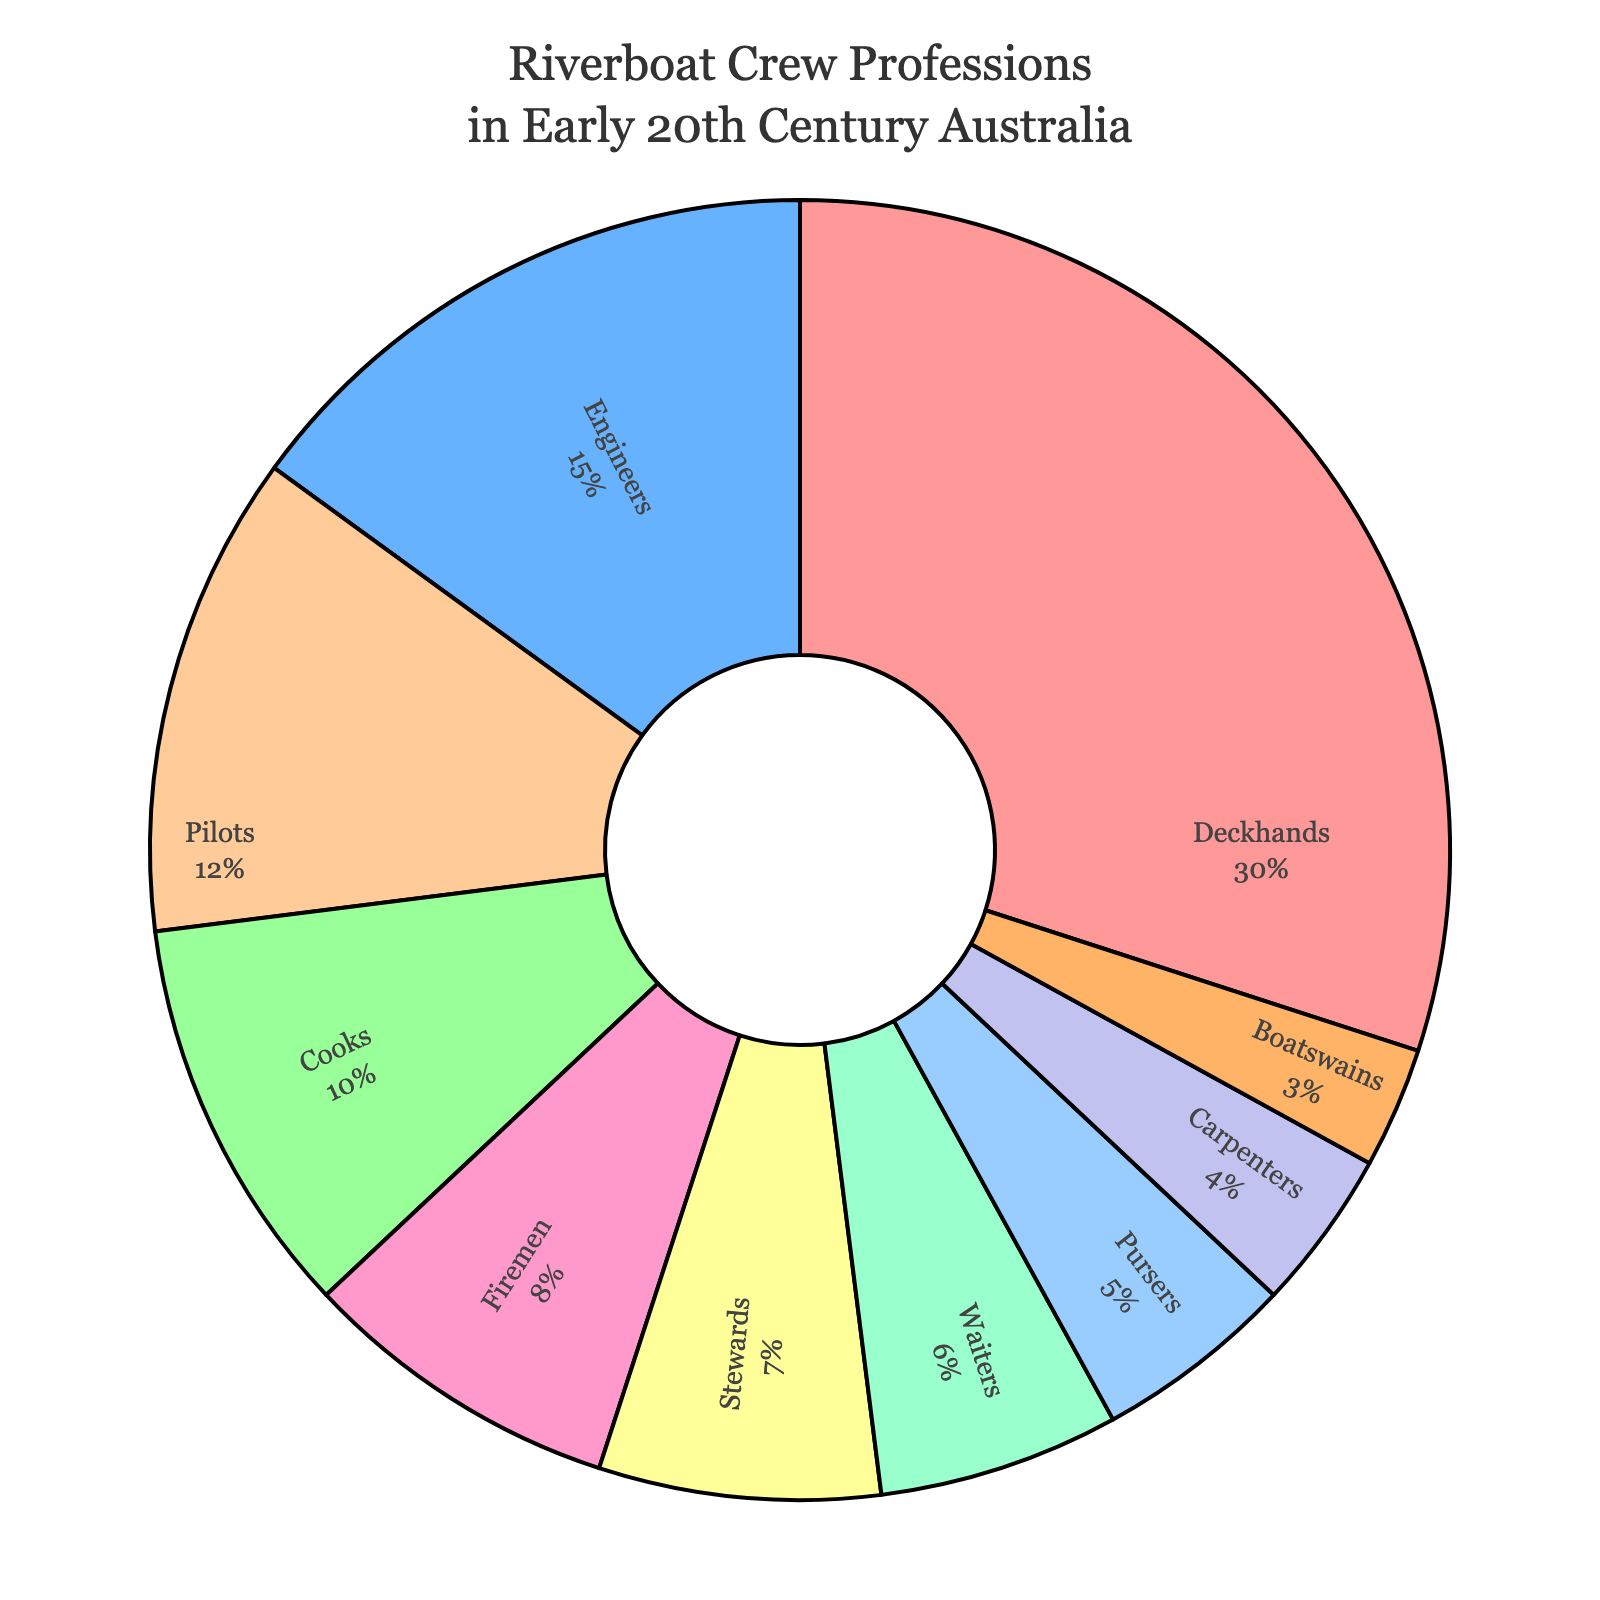Which profession has the highest percentage among riverboat crew members? The largest segment in the pie chart is for Deckhands, which has the highest percentage according to the legend.
Answer: Deckhands What is the total percentage of Deckhands, Engineers, and Cooks combined? To find the total percentage, add the individual percentages of these professions: Deckhands (30%), Engineers (15%), and Cooks (10%). So, 30% + 15% + 10% = 55%.
Answer: 55% Which profession has a smaller percentage: Stewards or Cooks? By comparing the two sections of the pie chart, we see that Cooks have 10% while Stewards have 7%, so Stewards have a smaller percentage.
Answer: Stewards What is the difference in percentage points between the professions with the highest and lowest percentages? The highest percentage is for Deckhands (30%), and the lowest is for Boatswains (3%). The difference is 30% - 3% = 27%.
Answer: 27% Which three professions have the smallest percentages, and what is their combined total percentage? The smallest percentages are for Boatswains (3%), Carpenters (4%), and Pursers (5%). Their combined total is 3% + 4% + 5% = 12%.
Answer: 12% Which segment is colored in red, and what percentage does it represent? The red segment on the pie chart corresponds to the Deckhands, which represents 30% of the total.
Answer: Deckhands, 30% If you consider Pilots and Cooks together, do they account for more or less than 20% of the crew members? Add the percentages for Pilots (12%) and Cooks (10%) together to see if their total is more or less than 20%: 12% + 10% = 22%, which is more than 20%.
Answer: More How many professions have a percentage greater than that of Waiters? Waiters have 6%. The professions with percentages greater than 6% are Deckhands (30%), Engineers (15%), Pilots (12%), Cooks (10%), Firemen (8%), and Stewards (7%). There are 6 professions with a greater percentage.
Answer: 6 Which profession constitutes exactly 8% of the crew members? According to the pie chart, the segment representing 8% corresponds to the Firemen.
Answer: Firemen 